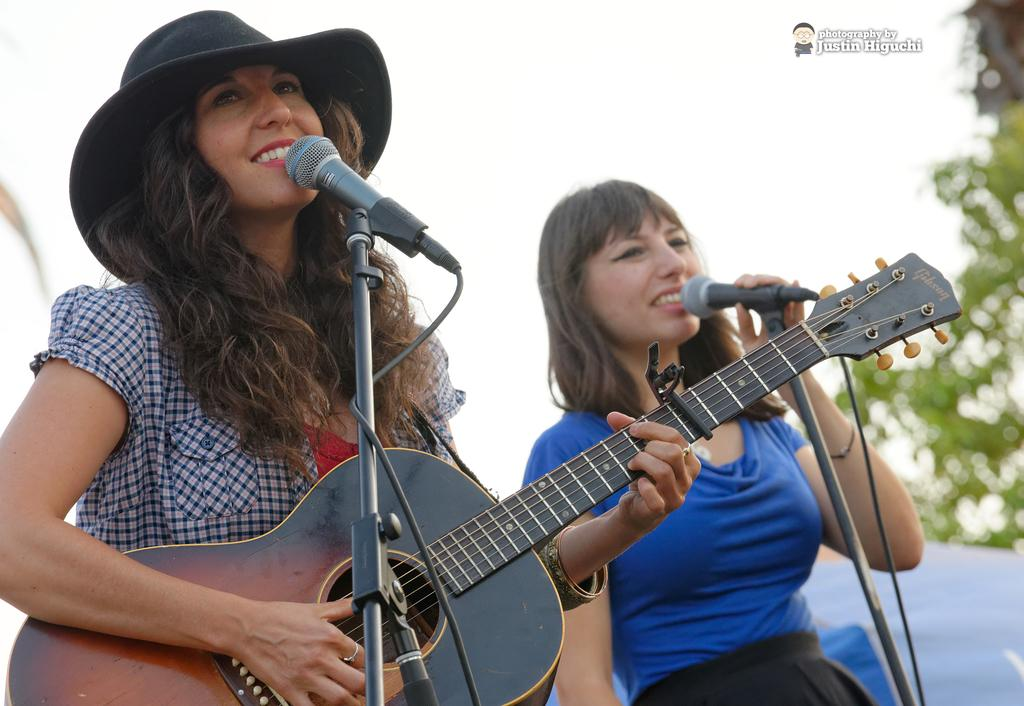How many women are in the image? There are two women in the image. What are the women doing in the image? Both women are standing, playing guitars, and singing on a microphone. Are the women playing the same instrument? Yes, both women are playing guitars. What type of ball can be seen on the floor near the women in the image? There is no ball present in the image. Is the image taken in a print shop or a lunchroom? The image does not provide any information about the location or setting, so it cannot be determined if it was taken in a print shop or a lunchroom. 